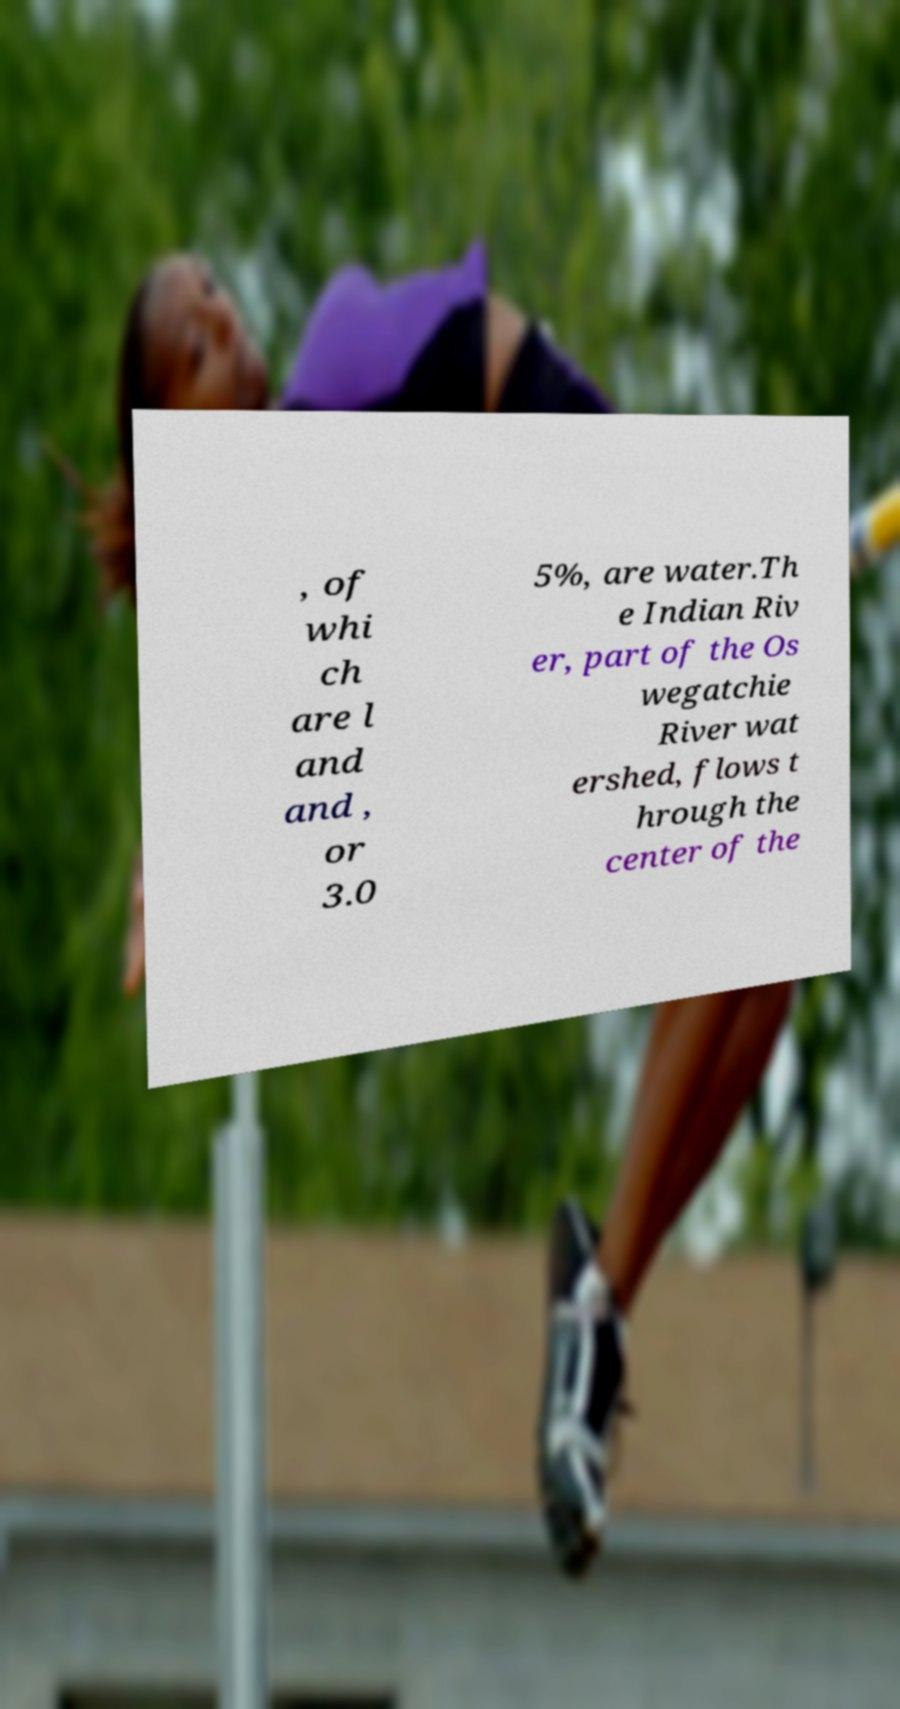There's text embedded in this image that I need extracted. Can you transcribe it verbatim? , of whi ch are l and and , or 3.0 5%, are water.Th e Indian Riv er, part of the Os wegatchie River wat ershed, flows t hrough the center of the 